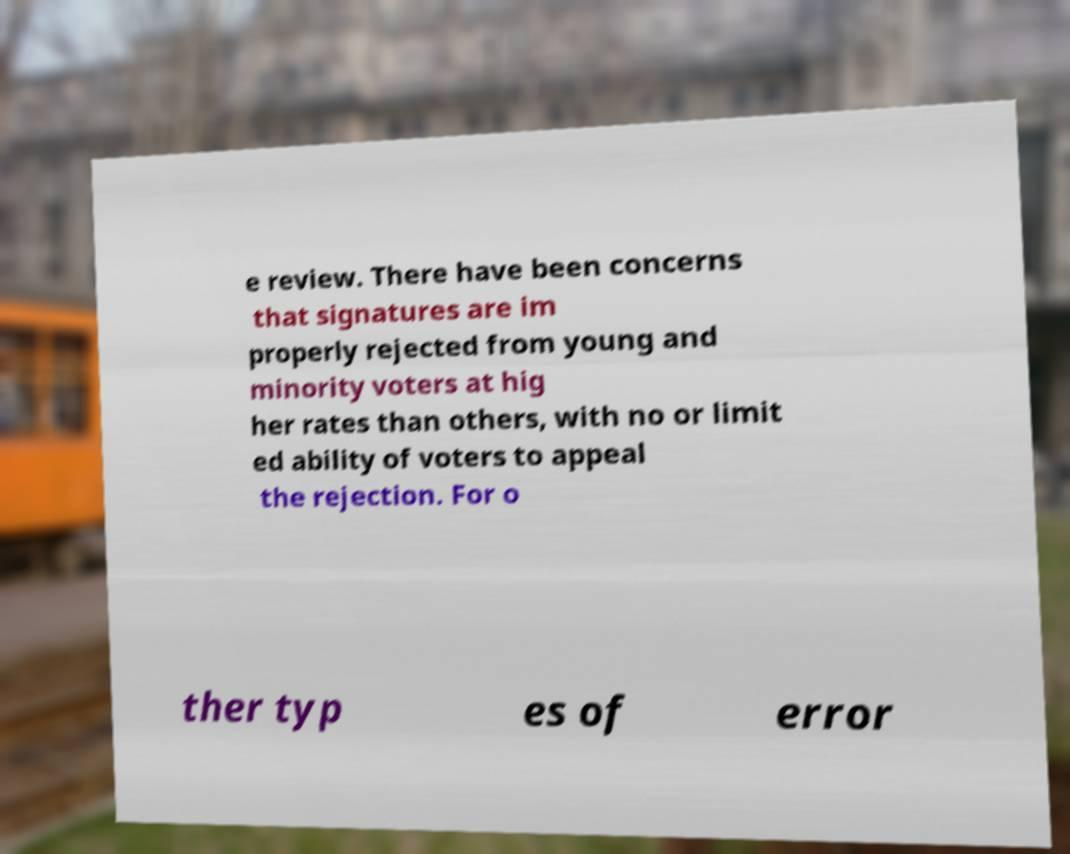For documentation purposes, I need the text within this image transcribed. Could you provide that? e review. There have been concerns that signatures are im properly rejected from young and minority voters at hig her rates than others, with no or limit ed ability of voters to appeal the rejection. For o ther typ es of error 